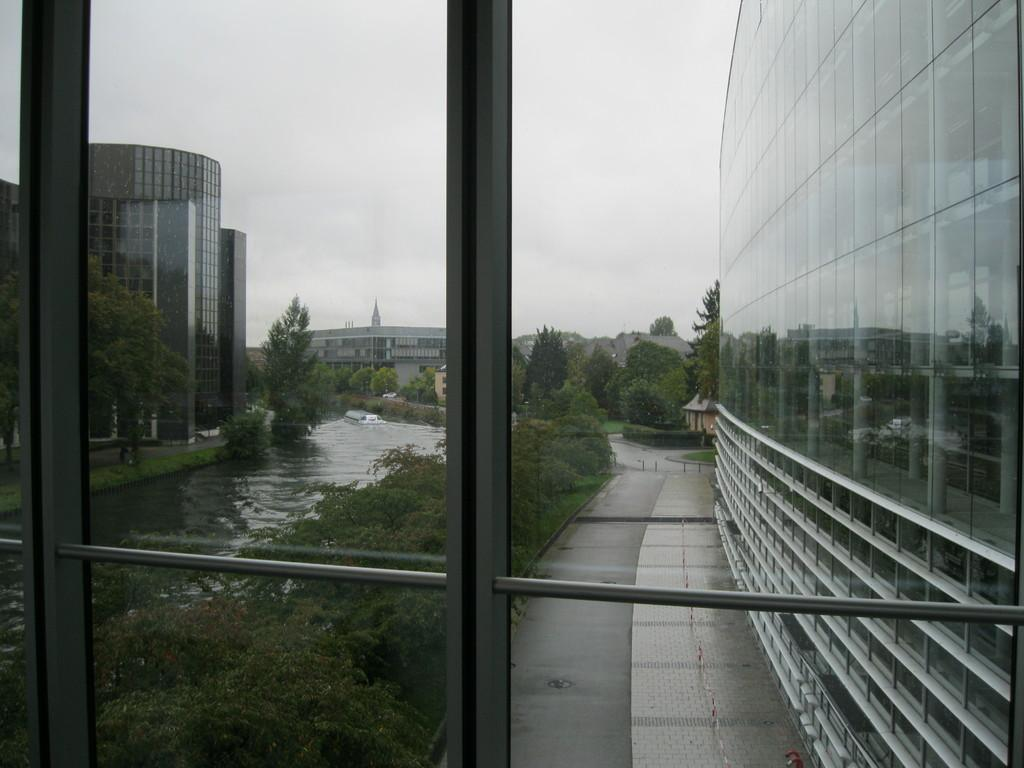What type of natural feature is present in the image? There is a lake in the image. What man-made structures can be seen in the image? There are buildings visible in the image. What type of vegetation is present in the image? There are trees in the image. What type of whip can be seen in the image? There is no whip present in the image. What type of truck is visible in the image? There is no truck present in the image. 